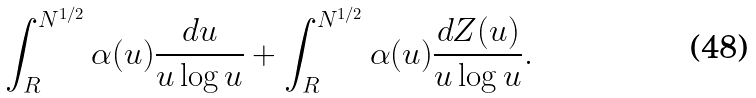Convert formula to latex. <formula><loc_0><loc_0><loc_500><loc_500>\int _ { R } ^ { N ^ { 1 / 2 } } \alpha ( u ) \frac { d u } { u \log u } + \int _ { R } ^ { N ^ { 1 / 2 } } \alpha ( u ) \frac { d Z ( u ) } { u \log u } .</formula> 